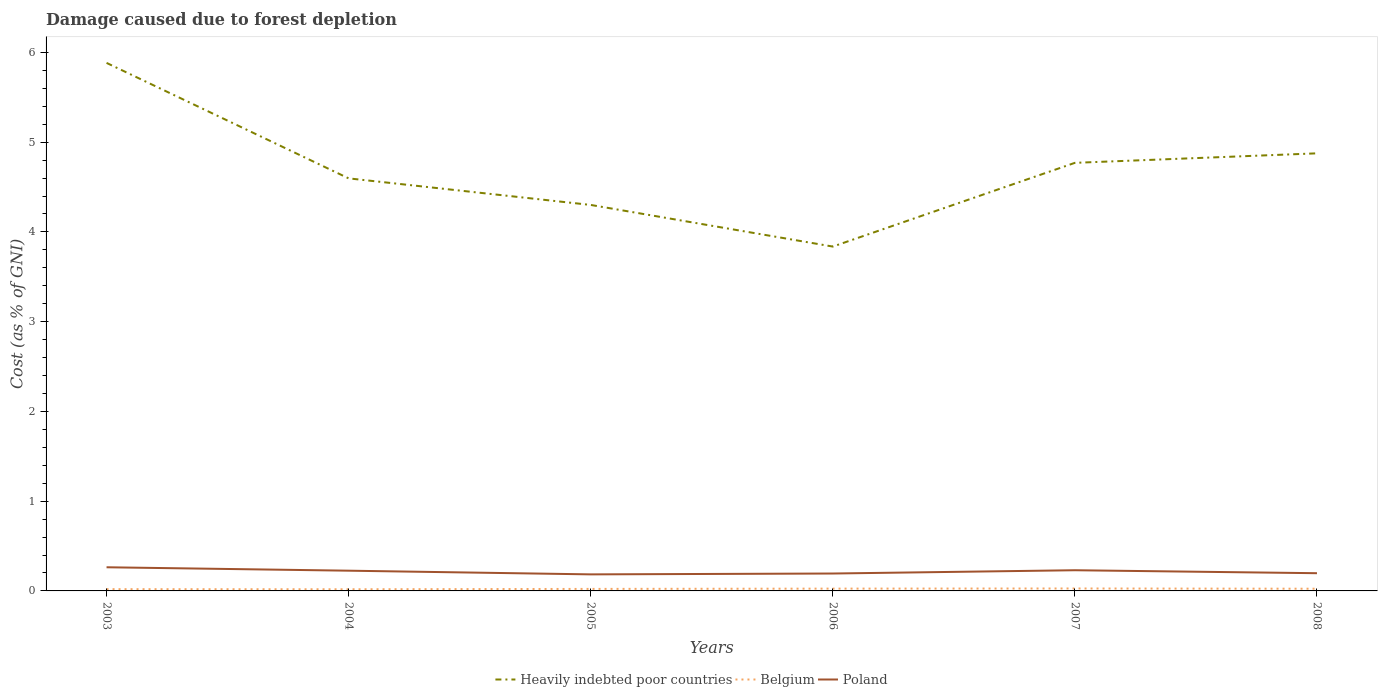How many different coloured lines are there?
Give a very brief answer. 3. Across all years, what is the maximum cost of damage caused due to forest depletion in Belgium?
Your response must be concise. 0.02. In which year was the cost of damage caused due to forest depletion in Belgium maximum?
Your answer should be compact. 2004. What is the total cost of damage caused due to forest depletion in Poland in the graph?
Make the answer very short. 0.03. What is the difference between the highest and the second highest cost of damage caused due to forest depletion in Poland?
Offer a terse response. 0.08. How many lines are there?
Your answer should be compact. 3. Are the values on the major ticks of Y-axis written in scientific E-notation?
Your response must be concise. No. How are the legend labels stacked?
Your answer should be very brief. Horizontal. What is the title of the graph?
Keep it short and to the point. Damage caused due to forest depletion. What is the label or title of the Y-axis?
Keep it short and to the point. Cost (as % of GNI). What is the Cost (as % of GNI) of Heavily indebted poor countries in 2003?
Provide a succinct answer. 5.88. What is the Cost (as % of GNI) in Belgium in 2003?
Keep it short and to the point. 0.02. What is the Cost (as % of GNI) in Poland in 2003?
Make the answer very short. 0.26. What is the Cost (as % of GNI) in Heavily indebted poor countries in 2004?
Ensure brevity in your answer.  4.6. What is the Cost (as % of GNI) of Belgium in 2004?
Give a very brief answer. 0.02. What is the Cost (as % of GNI) of Poland in 2004?
Keep it short and to the point. 0.23. What is the Cost (as % of GNI) in Heavily indebted poor countries in 2005?
Ensure brevity in your answer.  4.3. What is the Cost (as % of GNI) of Belgium in 2005?
Keep it short and to the point. 0.02. What is the Cost (as % of GNI) of Poland in 2005?
Ensure brevity in your answer.  0.18. What is the Cost (as % of GNI) of Heavily indebted poor countries in 2006?
Offer a terse response. 3.84. What is the Cost (as % of GNI) of Belgium in 2006?
Make the answer very short. 0.03. What is the Cost (as % of GNI) of Poland in 2006?
Your response must be concise. 0.19. What is the Cost (as % of GNI) of Heavily indebted poor countries in 2007?
Provide a short and direct response. 4.77. What is the Cost (as % of GNI) of Belgium in 2007?
Ensure brevity in your answer.  0.03. What is the Cost (as % of GNI) of Poland in 2007?
Make the answer very short. 0.23. What is the Cost (as % of GNI) in Heavily indebted poor countries in 2008?
Offer a very short reply. 4.88. What is the Cost (as % of GNI) in Belgium in 2008?
Your response must be concise. 0.02. What is the Cost (as % of GNI) in Poland in 2008?
Ensure brevity in your answer.  0.2. Across all years, what is the maximum Cost (as % of GNI) of Heavily indebted poor countries?
Your answer should be very brief. 5.88. Across all years, what is the maximum Cost (as % of GNI) in Belgium?
Your answer should be compact. 0.03. Across all years, what is the maximum Cost (as % of GNI) in Poland?
Ensure brevity in your answer.  0.26. Across all years, what is the minimum Cost (as % of GNI) in Heavily indebted poor countries?
Provide a succinct answer. 3.84. Across all years, what is the minimum Cost (as % of GNI) of Belgium?
Keep it short and to the point. 0.02. Across all years, what is the minimum Cost (as % of GNI) in Poland?
Provide a short and direct response. 0.18. What is the total Cost (as % of GNI) in Heavily indebted poor countries in the graph?
Your answer should be very brief. 28.26. What is the total Cost (as % of GNI) of Belgium in the graph?
Offer a very short reply. 0.14. What is the total Cost (as % of GNI) of Poland in the graph?
Your answer should be very brief. 1.3. What is the difference between the Cost (as % of GNI) of Heavily indebted poor countries in 2003 and that in 2004?
Provide a short and direct response. 1.29. What is the difference between the Cost (as % of GNI) in Belgium in 2003 and that in 2004?
Offer a very short reply. 0. What is the difference between the Cost (as % of GNI) in Poland in 2003 and that in 2004?
Ensure brevity in your answer.  0.04. What is the difference between the Cost (as % of GNI) of Heavily indebted poor countries in 2003 and that in 2005?
Ensure brevity in your answer.  1.58. What is the difference between the Cost (as % of GNI) of Belgium in 2003 and that in 2005?
Ensure brevity in your answer.  -0. What is the difference between the Cost (as % of GNI) in Poland in 2003 and that in 2005?
Offer a very short reply. 0.08. What is the difference between the Cost (as % of GNI) of Heavily indebted poor countries in 2003 and that in 2006?
Your answer should be compact. 2.05. What is the difference between the Cost (as % of GNI) of Belgium in 2003 and that in 2006?
Make the answer very short. -0.01. What is the difference between the Cost (as % of GNI) of Poland in 2003 and that in 2006?
Offer a very short reply. 0.07. What is the difference between the Cost (as % of GNI) of Heavily indebted poor countries in 2003 and that in 2007?
Your response must be concise. 1.11. What is the difference between the Cost (as % of GNI) of Belgium in 2003 and that in 2007?
Provide a succinct answer. -0.01. What is the difference between the Cost (as % of GNI) in Poland in 2003 and that in 2007?
Give a very brief answer. 0.03. What is the difference between the Cost (as % of GNI) of Heavily indebted poor countries in 2003 and that in 2008?
Your answer should be very brief. 1.01. What is the difference between the Cost (as % of GNI) of Belgium in 2003 and that in 2008?
Your answer should be compact. -0. What is the difference between the Cost (as % of GNI) of Poland in 2003 and that in 2008?
Your response must be concise. 0.07. What is the difference between the Cost (as % of GNI) in Heavily indebted poor countries in 2004 and that in 2005?
Ensure brevity in your answer.  0.3. What is the difference between the Cost (as % of GNI) of Belgium in 2004 and that in 2005?
Provide a succinct answer. -0. What is the difference between the Cost (as % of GNI) in Poland in 2004 and that in 2005?
Provide a short and direct response. 0.04. What is the difference between the Cost (as % of GNI) in Heavily indebted poor countries in 2004 and that in 2006?
Provide a short and direct response. 0.76. What is the difference between the Cost (as % of GNI) in Belgium in 2004 and that in 2006?
Keep it short and to the point. -0.01. What is the difference between the Cost (as % of GNI) of Poland in 2004 and that in 2006?
Ensure brevity in your answer.  0.03. What is the difference between the Cost (as % of GNI) in Heavily indebted poor countries in 2004 and that in 2007?
Your answer should be compact. -0.17. What is the difference between the Cost (as % of GNI) in Belgium in 2004 and that in 2007?
Your answer should be very brief. -0.01. What is the difference between the Cost (as % of GNI) of Poland in 2004 and that in 2007?
Keep it short and to the point. -0. What is the difference between the Cost (as % of GNI) of Heavily indebted poor countries in 2004 and that in 2008?
Ensure brevity in your answer.  -0.28. What is the difference between the Cost (as % of GNI) in Belgium in 2004 and that in 2008?
Make the answer very short. -0.01. What is the difference between the Cost (as % of GNI) of Poland in 2004 and that in 2008?
Make the answer very short. 0.03. What is the difference between the Cost (as % of GNI) in Heavily indebted poor countries in 2005 and that in 2006?
Offer a very short reply. 0.46. What is the difference between the Cost (as % of GNI) of Belgium in 2005 and that in 2006?
Your response must be concise. -0. What is the difference between the Cost (as % of GNI) in Poland in 2005 and that in 2006?
Give a very brief answer. -0.01. What is the difference between the Cost (as % of GNI) in Heavily indebted poor countries in 2005 and that in 2007?
Your response must be concise. -0.47. What is the difference between the Cost (as % of GNI) of Belgium in 2005 and that in 2007?
Provide a short and direct response. -0. What is the difference between the Cost (as % of GNI) of Poland in 2005 and that in 2007?
Make the answer very short. -0.05. What is the difference between the Cost (as % of GNI) in Heavily indebted poor countries in 2005 and that in 2008?
Your answer should be compact. -0.57. What is the difference between the Cost (as % of GNI) in Belgium in 2005 and that in 2008?
Offer a very short reply. -0. What is the difference between the Cost (as % of GNI) of Poland in 2005 and that in 2008?
Give a very brief answer. -0.01. What is the difference between the Cost (as % of GNI) in Heavily indebted poor countries in 2006 and that in 2007?
Ensure brevity in your answer.  -0.93. What is the difference between the Cost (as % of GNI) in Belgium in 2006 and that in 2007?
Your response must be concise. -0. What is the difference between the Cost (as % of GNI) of Poland in 2006 and that in 2007?
Provide a succinct answer. -0.04. What is the difference between the Cost (as % of GNI) in Heavily indebted poor countries in 2006 and that in 2008?
Make the answer very short. -1.04. What is the difference between the Cost (as % of GNI) of Belgium in 2006 and that in 2008?
Offer a terse response. 0. What is the difference between the Cost (as % of GNI) of Poland in 2006 and that in 2008?
Your answer should be compact. -0. What is the difference between the Cost (as % of GNI) in Heavily indebted poor countries in 2007 and that in 2008?
Offer a very short reply. -0.11. What is the difference between the Cost (as % of GNI) in Belgium in 2007 and that in 2008?
Your response must be concise. 0. What is the difference between the Cost (as % of GNI) of Poland in 2007 and that in 2008?
Offer a very short reply. 0.03. What is the difference between the Cost (as % of GNI) of Heavily indebted poor countries in 2003 and the Cost (as % of GNI) of Belgium in 2004?
Provide a succinct answer. 5.87. What is the difference between the Cost (as % of GNI) of Heavily indebted poor countries in 2003 and the Cost (as % of GNI) of Poland in 2004?
Make the answer very short. 5.66. What is the difference between the Cost (as % of GNI) of Belgium in 2003 and the Cost (as % of GNI) of Poland in 2004?
Your answer should be very brief. -0.21. What is the difference between the Cost (as % of GNI) in Heavily indebted poor countries in 2003 and the Cost (as % of GNI) in Belgium in 2005?
Make the answer very short. 5.86. What is the difference between the Cost (as % of GNI) in Heavily indebted poor countries in 2003 and the Cost (as % of GNI) in Poland in 2005?
Offer a very short reply. 5.7. What is the difference between the Cost (as % of GNI) in Belgium in 2003 and the Cost (as % of GNI) in Poland in 2005?
Your answer should be very brief. -0.16. What is the difference between the Cost (as % of GNI) in Heavily indebted poor countries in 2003 and the Cost (as % of GNI) in Belgium in 2006?
Keep it short and to the point. 5.86. What is the difference between the Cost (as % of GNI) of Heavily indebted poor countries in 2003 and the Cost (as % of GNI) of Poland in 2006?
Your answer should be very brief. 5.69. What is the difference between the Cost (as % of GNI) in Belgium in 2003 and the Cost (as % of GNI) in Poland in 2006?
Offer a very short reply. -0.17. What is the difference between the Cost (as % of GNI) of Heavily indebted poor countries in 2003 and the Cost (as % of GNI) of Belgium in 2007?
Your response must be concise. 5.86. What is the difference between the Cost (as % of GNI) in Heavily indebted poor countries in 2003 and the Cost (as % of GNI) in Poland in 2007?
Your answer should be compact. 5.65. What is the difference between the Cost (as % of GNI) of Belgium in 2003 and the Cost (as % of GNI) of Poland in 2007?
Your response must be concise. -0.21. What is the difference between the Cost (as % of GNI) in Heavily indebted poor countries in 2003 and the Cost (as % of GNI) in Belgium in 2008?
Your answer should be compact. 5.86. What is the difference between the Cost (as % of GNI) of Heavily indebted poor countries in 2003 and the Cost (as % of GNI) of Poland in 2008?
Make the answer very short. 5.69. What is the difference between the Cost (as % of GNI) of Belgium in 2003 and the Cost (as % of GNI) of Poland in 2008?
Your answer should be very brief. -0.18. What is the difference between the Cost (as % of GNI) in Heavily indebted poor countries in 2004 and the Cost (as % of GNI) in Belgium in 2005?
Ensure brevity in your answer.  4.57. What is the difference between the Cost (as % of GNI) of Heavily indebted poor countries in 2004 and the Cost (as % of GNI) of Poland in 2005?
Your response must be concise. 4.41. What is the difference between the Cost (as % of GNI) in Belgium in 2004 and the Cost (as % of GNI) in Poland in 2005?
Your answer should be very brief. -0.17. What is the difference between the Cost (as % of GNI) of Heavily indebted poor countries in 2004 and the Cost (as % of GNI) of Belgium in 2006?
Offer a terse response. 4.57. What is the difference between the Cost (as % of GNI) of Heavily indebted poor countries in 2004 and the Cost (as % of GNI) of Poland in 2006?
Your response must be concise. 4.4. What is the difference between the Cost (as % of GNI) in Belgium in 2004 and the Cost (as % of GNI) in Poland in 2006?
Ensure brevity in your answer.  -0.18. What is the difference between the Cost (as % of GNI) of Heavily indebted poor countries in 2004 and the Cost (as % of GNI) of Belgium in 2007?
Provide a short and direct response. 4.57. What is the difference between the Cost (as % of GNI) in Heavily indebted poor countries in 2004 and the Cost (as % of GNI) in Poland in 2007?
Make the answer very short. 4.37. What is the difference between the Cost (as % of GNI) in Belgium in 2004 and the Cost (as % of GNI) in Poland in 2007?
Offer a very short reply. -0.21. What is the difference between the Cost (as % of GNI) of Heavily indebted poor countries in 2004 and the Cost (as % of GNI) of Belgium in 2008?
Make the answer very short. 4.57. What is the difference between the Cost (as % of GNI) of Heavily indebted poor countries in 2004 and the Cost (as % of GNI) of Poland in 2008?
Make the answer very short. 4.4. What is the difference between the Cost (as % of GNI) of Belgium in 2004 and the Cost (as % of GNI) of Poland in 2008?
Your response must be concise. -0.18. What is the difference between the Cost (as % of GNI) in Heavily indebted poor countries in 2005 and the Cost (as % of GNI) in Belgium in 2006?
Provide a short and direct response. 4.28. What is the difference between the Cost (as % of GNI) in Heavily indebted poor countries in 2005 and the Cost (as % of GNI) in Poland in 2006?
Make the answer very short. 4.11. What is the difference between the Cost (as % of GNI) of Belgium in 2005 and the Cost (as % of GNI) of Poland in 2006?
Keep it short and to the point. -0.17. What is the difference between the Cost (as % of GNI) in Heavily indebted poor countries in 2005 and the Cost (as % of GNI) in Belgium in 2007?
Keep it short and to the point. 4.27. What is the difference between the Cost (as % of GNI) of Heavily indebted poor countries in 2005 and the Cost (as % of GNI) of Poland in 2007?
Keep it short and to the point. 4.07. What is the difference between the Cost (as % of GNI) of Belgium in 2005 and the Cost (as % of GNI) of Poland in 2007?
Offer a very short reply. -0.21. What is the difference between the Cost (as % of GNI) in Heavily indebted poor countries in 2005 and the Cost (as % of GNI) in Belgium in 2008?
Provide a succinct answer. 4.28. What is the difference between the Cost (as % of GNI) of Heavily indebted poor countries in 2005 and the Cost (as % of GNI) of Poland in 2008?
Keep it short and to the point. 4.1. What is the difference between the Cost (as % of GNI) in Belgium in 2005 and the Cost (as % of GNI) in Poland in 2008?
Provide a succinct answer. -0.17. What is the difference between the Cost (as % of GNI) of Heavily indebted poor countries in 2006 and the Cost (as % of GNI) of Belgium in 2007?
Ensure brevity in your answer.  3.81. What is the difference between the Cost (as % of GNI) in Heavily indebted poor countries in 2006 and the Cost (as % of GNI) in Poland in 2007?
Offer a very short reply. 3.61. What is the difference between the Cost (as % of GNI) of Belgium in 2006 and the Cost (as % of GNI) of Poland in 2007?
Your answer should be compact. -0.2. What is the difference between the Cost (as % of GNI) in Heavily indebted poor countries in 2006 and the Cost (as % of GNI) in Belgium in 2008?
Keep it short and to the point. 3.81. What is the difference between the Cost (as % of GNI) in Heavily indebted poor countries in 2006 and the Cost (as % of GNI) in Poland in 2008?
Offer a terse response. 3.64. What is the difference between the Cost (as % of GNI) in Belgium in 2006 and the Cost (as % of GNI) in Poland in 2008?
Provide a short and direct response. -0.17. What is the difference between the Cost (as % of GNI) in Heavily indebted poor countries in 2007 and the Cost (as % of GNI) in Belgium in 2008?
Provide a succinct answer. 4.75. What is the difference between the Cost (as % of GNI) of Heavily indebted poor countries in 2007 and the Cost (as % of GNI) of Poland in 2008?
Make the answer very short. 4.57. What is the difference between the Cost (as % of GNI) of Belgium in 2007 and the Cost (as % of GNI) of Poland in 2008?
Make the answer very short. -0.17. What is the average Cost (as % of GNI) in Heavily indebted poor countries per year?
Your answer should be very brief. 4.71. What is the average Cost (as % of GNI) of Belgium per year?
Offer a terse response. 0.02. What is the average Cost (as % of GNI) of Poland per year?
Offer a terse response. 0.22. In the year 2003, what is the difference between the Cost (as % of GNI) of Heavily indebted poor countries and Cost (as % of GNI) of Belgium?
Keep it short and to the point. 5.86. In the year 2003, what is the difference between the Cost (as % of GNI) of Heavily indebted poor countries and Cost (as % of GNI) of Poland?
Offer a terse response. 5.62. In the year 2003, what is the difference between the Cost (as % of GNI) in Belgium and Cost (as % of GNI) in Poland?
Offer a terse response. -0.24. In the year 2004, what is the difference between the Cost (as % of GNI) in Heavily indebted poor countries and Cost (as % of GNI) in Belgium?
Give a very brief answer. 4.58. In the year 2004, what is the difference between the Cost (as % of GNI) in Heavily indebted poor countries and Cost (as % of GNI) in Poland?
Keep it short and to the point. 4.37. In the year 2004, what is the difference between the Cost (as % of GNI) of Belgium and Cost (as % of GNI) of Poland?
Keep it short and to the point. -0.21. In the year 2005, what is the difference between the Cost (as % of GNI) of Heavily indebted poor countries and Cost (as % of GNI) of Belgium?
Your answer should be compact. 4.28. In the year 2005, what is the difference between the Cost (as % of GNI) of Heavily indebted poor countries and Cost (as % of GNI) of Poland?
Keep it short and to the point. 4.12. In the year 2005, what is the difference between the Cost (as % of GNI) in Belgium and Cost (as % of GNI) in Poland?
Provide a short and direct response. -0.16. In the year 2006, what is the difference between the Cost (as % of GNI) in Heavily indebted poor countries and Cost (as % of GNI) in Belgium?
Your answer should be compact. 3.81. In the year 2006, what is the difference between the Cost (as % of GNI) in Heavily indebted poor countries and Cost (as % of GNI) in Poland?
Provide a succinct answer. 3.64. In the year 2006, what is the difference between the Cost (as % of GNI) in Belgium and Cost (as % of GNI) in Poland?
Your answer should be compact. -0.17. In the year 2007, what is the difference between the Cost (as % of GNI) of Heavily indebted poor countries and Cost (as % of GNI) of Belgium?
Make the answer very short. 4.74. In the year 2007, what is the difference between the Cost (as % of GNI) in Heavily indebted poor countries and Cost (as % of GNI) in Poland?
Make the answer very short. 4.54. In the year 2007, what is the difference between the Cost (as % of GNI) of Belgium and Cost (as % of GNI) of Poland?
Provide a succinct answer. -0.2. In the year 2008, what is the difference between the Cost (as % of GNI) in Heavily indebted poor countries and Cost (as % of GNI) in Belgium?
Give a very brief answer. 4.85. In the year 2008, what is the difference between the Cost (as % of GNI) of Heavily indebted poor countries and Cost (as % of GNI) of Poland?
Keep it short and to the point. 4.68. In the year 2008, what is the difference between the Cost (as % of GNI) in Belgium and Cost (as % of GNI) in Poland?
Offer a very short reply. -0.17. What is the ratio of the Cost (as % of GNI) of Heavily indebted poor countries in 2003 to that in 2004?
Offer a terse response. 1.28. What is the ratio of the Cost (as % of GNI) in Belgium in 2003 to that in 2004?
Ensure brevity in your answer.  1.06. What is the ratio of the Cost (as % of GNI) of Poland in 2003 to that in 2004?
Offer a terse response. 1.17. What is the ratio of the Cost (as % of GNI) in Heavily indebted poor countries in 2003 to that in 2005?
Your response must be concise. 1.37. What is the ratio of the Cost (as % of GNI) of Belgium in 2003 to that in 2005?
Your answer should be very brief. 0.88. What is the ratio of the Cost (as % of GNI) in Poland in 2003 to that in 2005?
Make the answer very short. 1.43. What is the ratio of the Cost (as % of GNI) in Heavily indebted poor countries in 2003 to that in 2006?
Your answer should be compact. 1.53. What is the ratio of the Cost (as % of GNI) of Belgium in 2003 to that in 2006?
Ensure brevity in your answer.  0.77. What is the ratio of the Cost (as % of GNI) of Poland in 2003 to that in 2006?
Ensure brevity in your answer.  1.36. What is the ratio of the Cost (as % of GNI) in Heavily indebted poor countries in 2003 to that in 2007?
Ensure brevity in your answer.  1.23. What is the ratio of the Cost (as % of GNI) of Belgium in 2003 to that in 2007?
Your response must be concise. 0.72. What is the ratio of the Cost (as % of GNI) in Poland in 2003 to that in 2007?
Offer a terse response. 1.14. What is the ratio of the Cost (as % of GNI) in Heavily indebted poor countries in 2003 to that in 2008?
Give a very brief answer. 1.21. What is the ratio of the Cost (as % of GNI) in Belgium in 2003 to that in 2008?
Your answer should be compact. 0.81. What is the ratio of the Cost (as % of GNI) of Poland in 2003 to that in 2008?
Your response must be concise. 1.34. What is the ratio of the Cost (as % of GNI) in Heavily indebted poor countries in 2004 to that in 2005?
Make the answer very short. 1.07. What is the ratio of the Cost (as % of GNI) in Belgium in 2004 to that in 2005?
Provide a short and direct response. 0.82. What is the ratio of the Cost (as % of GNI) in Poland in 2004 to that in 2005?
Make the answer very short. 1.22. What is the ratio of the Cost (as % of GNI) of Heavily indebted poor countries in 2004 to that in 2006?
Ensure brevity in your answer.  1.2. What is the ratio of the Cost (as % of GNI) in Belgium in 2004 to that in 2006?
Your answer should be very brief. 0.72. What is the ratio of the Cost (as % of GNI) of Poland in 2004 to that in 2006?
Offer a terse response. 1.16. What is the ratio of the Cost (as % of GNI) of Heavily indebted poor countries in 2004 to that in 2007?
Your response must be concise. 0.96. What is the ratio of the Cost (as % of GNI) of Belgium in 2004 to that in 2007?
Your answer should be compact. 0.68. What is the ratio of the Cost (as % of GNI) in Poland in 2004 to that in 2007?
Provide a succinct answer. 0.98. What is the ratio of the Cost (as % of GNI) of Heavily indebted poor countries in 2004 to that in 2008?
Your answer should be very brief. 0.94. What is the ratio of the Cost (as % of GNI) in Belgium in 2004 to that in 2008?
Your answer should be compact. 0.76. What is the ratio of the Cost (as % of GNI) in Poland in 2004 to that in 2008?
Ensure brevity in your answer.  1.14. What is the ratio of the Cost (as % of GNI) in Heavily indebted poor countries in 2005 to that in 2006?
Your response must be concise. 1.12. What is the ratio of the Cost (as % of GNI) in Belgium in 2005 to that in 2006?
Provide a short and direct response. 0.88. What is the ratio of the Cost (as % of GNI) in Poland in 2005 to that in 2006?
Offer a terse response. 0.95. What is the ratio of the Cost (as % of GNI) in Heavily indebted poor countries in 2005 to that in 2007?
Ensure brevity in your answer.  0.9. What is the ratio of the Cost (as % of GNI) of Belgium in 2005 to that in 2007?
Keep it short and to the point. 0.82. What is the ratio of the Cost (as % of GNI) in Heavily indebted poor countries in 2005 to that in 2008?
Provide a short and direct response. 0.88. What is the ratio of the Cost (as % of GNI) in Belgium in 2005 to that in 2008?
Your response must be concise. 0.92. What is the ratio of the Cost (as % of GNI) of Poland in 2005 to that in 2008?
Offer a terse response. 0.93. What is the ratio of the Cost (as % of GNI) in Heavily indebted poor countries in 2006 to that in 2007?
Provide a short and direct response. 0.8. What is the ratio of the Cost (as % of GNI) in Belgium in 2006 to that in 2007?
Give a very brief answer. 0.94. What is the ratio of the Cost (as % of GNI) of Poland in 2006 to that in 2007?
Ensure brevity in your answer.  0.84. What is the ratio of the Cost (as % of GNI) in Heavily indebted poor countries in 2006 to that in 2008?
Your answer should be compact. 0.79. What is the ratio of the Cost (as % of GNI) of Belgium in 2006 to that in 2008?
Keep it short and to the point. 1.05. What is the ratio of the Cost (as % of GNI) of Poland in 2006 to that in 2008?
Offer a very short reply. 0.98. What is the ratio of the Cost (as % of GNI) in Heavily indebted poor countries in 2007 to that in 2008?
Your answer should be compact. 0.98. What is the ratio of the Cost (as % of GNI) of Belgium in 2007 to that in 2008?
Give a very brief answer. 1.11. What is the ratio of the Cost (as % of GNI) of Poland in 2007 to that in 2008?
Your answer should be compact. 1.17. What is the difference between the highest and the second highest Cost (as % of GNI) of Heavily indebted poor countries?
Your response must be concise. 1.01. What is the difference between the highest and the second highest Cost (as % of GNI) of Belgium?
Give a very brief answer. 0. What is the difference between the highest and the second highest Cost (as % of GNI) in Poland?
Offer a very short reply. 0.03. What is the difference between the highest and the lowest Cost (as % of GNI) of Heavily indebted poor countries?
Ensure brevity in your answer.  2.05. What is the difference between the highest and the lowest Cost (as % of GNI) in Belgium?
Give a very brief answer. 0.01. What is the difference between the highest and the lowest Cost (as % of GNI) in Poland?
Your answer should be very brief. 0.08. 